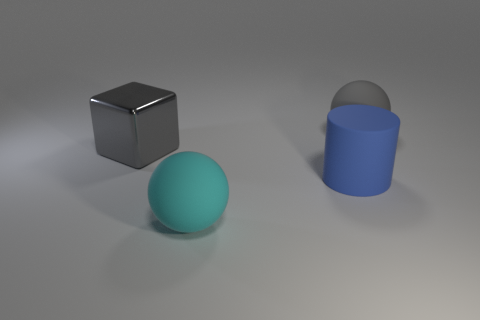The other big object that is the same color as the shiny thing is what shape? The other large object that shares the same color as the reflective cube is a cylinder. 